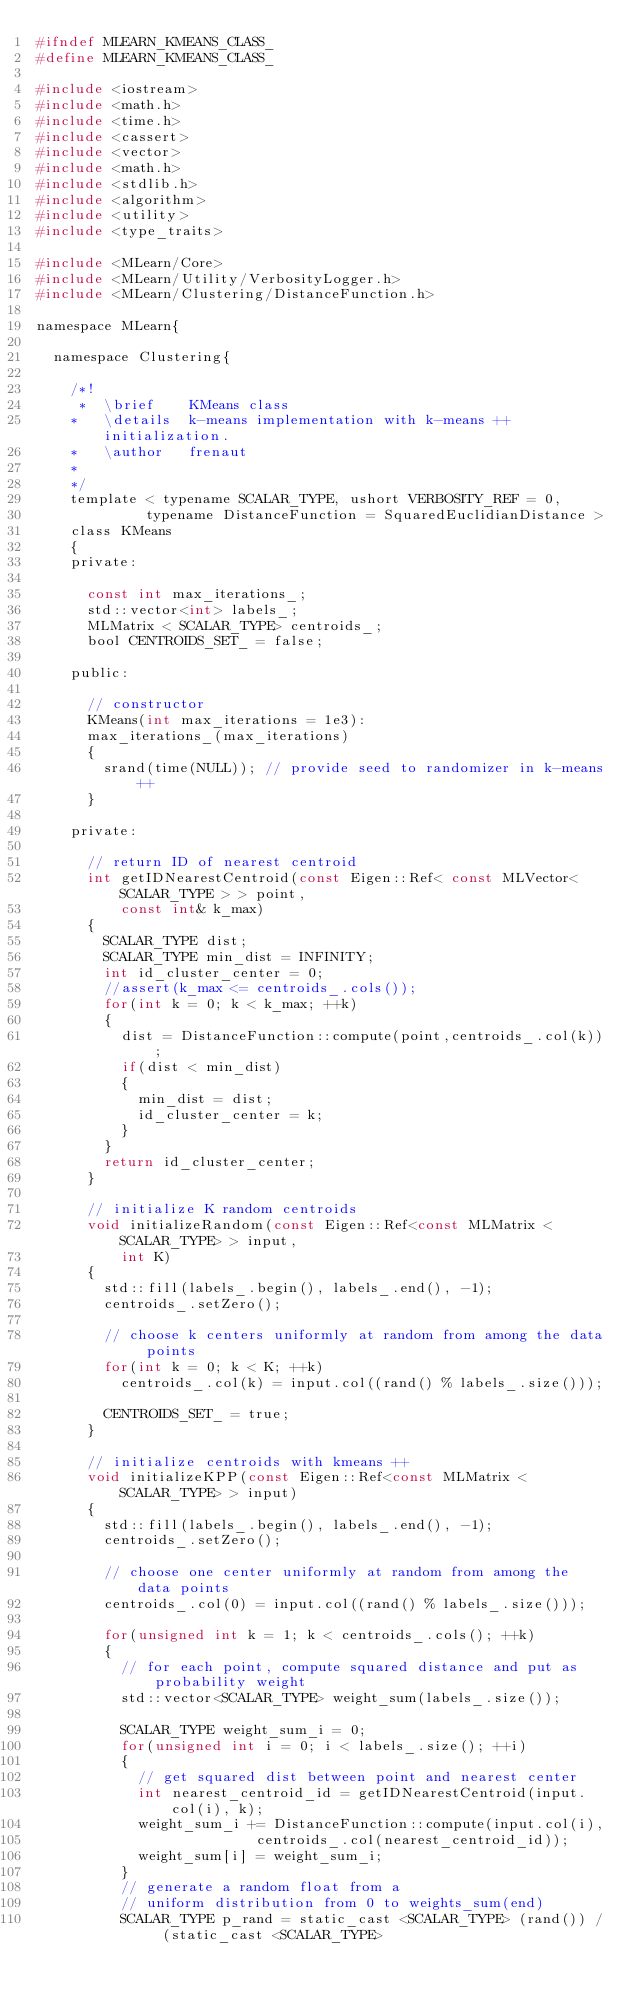<code> <loc_0><loc_0><loc_500><loc_500><_C_>#ifndef MLEARN_KMEANS_CLASS_
#define MLEARN_KMEANS_CLASS_

#include <iostream>
#include <math.h>
#include <time.h>
#include <cassert>
#include <vector>
#include <math.h>
#include <stdlib.h>
#include <algorithm>
#include <utility>
#include <type_traits>

#include <MLearn/Core>
#include <MLearn/Utility/VerbosityLogger.h>
#include <MLearn/Clustering/DistanceFunction.h>

namespace MLearn{

  namespace Clustering{

    /*!
     *  \brief    KMeans class
    *   \details  k-means implementation with k-means ++ initialization.
    *   \author   frenaut
    *
    */
    template < typename SCALAR_TYPE, ushort VERBOSITY_REF = 0, 
             typename DistanceFunction = SquaredEuclidianDistance >
    class KMeans
    {
    private:

      const int max_iterations_;
      std::vector<int> labels_;
      MLMatrix < SCALAR_TYPE> centroids_;
      bool CENTROIDS_SET_ = false;

    public:

      // constructor
      KMeans(int max_iterations = 1e3):
      max_iterations_(max_iterations)
      {
        srand(time(NULL)); // provide seed to randomizer in k-means++
      }

    private:

      // return ID of nearest centroid 
      int getIDNearestCentroid(const Eigen::Ref< const MLVector< SCALAR_TYPE > > point,
          const int& k_max)
      {
        SCALAR_TYPE dist;
        SCALAR_TYPE min_dist = INFINITY;
        int id_cluster_center = 0;
        //assert(k_max <= centroids_.cols());
        for(int k = 0; k < k_max; ++k)
        {	
          dist = DistanceFunction::compute(point,centroids_.col(k));
          if(dist < min_dist)
          {
            min_dist = dist;
            id_cluster_center = k;
          }
        }
        return id_cluster_center;
      }

      // initialize K random centroids
      void initializeRandom(const Eigen::Ref<const MLMatrix <SCALAR_TYPE> > input, 
          int K)
      {
        std::fill(labels_.begin(), labels_.end(), -1);
        centroids_.setZero();

        // choose k centers uniformly at random from among the data points
        for(int k = 0; k < K; ++k)
          centroids_.col(k) = input.col((rand() % labels_.size()));

        CENTROIDS_SET_ = true;
      }
      
      // initialize centroids with kmeans ++
      void initializeKPP(const Eigen::Ref<const MLMatrix <SCALAR_TYPE> > input)
      {
        std::fill(labels_.begin(), labels_.end(), -1);
        centroids_.setZero();

        // choose one center uniformly at random from among the data points
        centroids_.col(0) = input.col((rand() % labels_.size()));

        for(unsigned int k = 1; k < centroids_.cols(); ++k)
        {	
          // for each point, compute squared distance and put as probability weight
          std::vector<SCALAR_TYPE> weight_sum(labels_.size());
          
          SCALAR_TYPE weight_sum_i = 0;
          for(unsigned int i = 0; i < labels_.size(); ++i)
          {
            // get squared dist between point and nearest center
            int nearest_centroid_id = getIDNearestCentroid(input.col(i), k);
            weight_sum_i += DistanceFunction::compute(input.col(i),
                          centroids_.col(nearest_centroid_id));
            weight_sum[i] = weight_sum_i;
          }
          // generate a random float from a 
          // uniform distribution from 0 to weights_sum(end)
          SCALAR_TYPE p_rand = static_cast <SCALAR_TYPE> (rand()) / (static_cast <SCALAR_TYPE></code> 